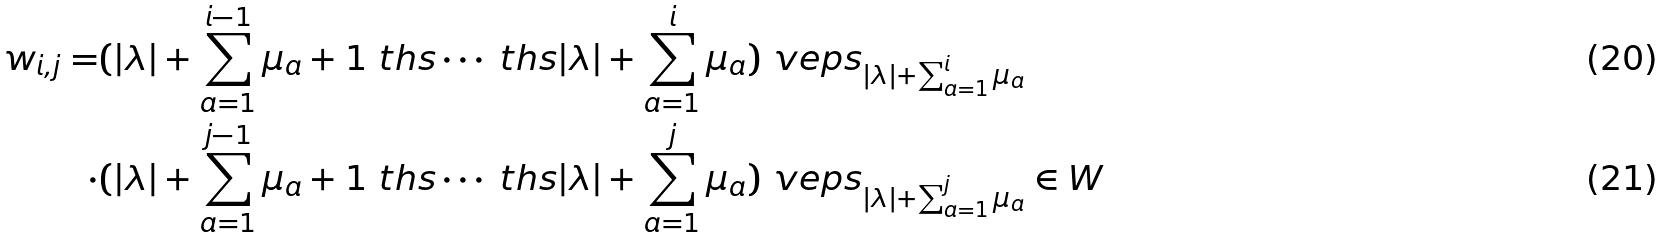<formula> <loc_0><loc_0><loc_500><loc_500>w _ { i , j } = & ( | \lambda | + \sum _ { a = 1 } ^ { i - 1 } \mu _ { a } + 1 \ t h s \cdots \ t h s | \lambda | + \sum _ { a = 1 } ^ { i } \mu _ { a } ) \ v e p s _ { | \lambda | + \sum _ { a = 1 } ^ { i } \mu _ { a } } \\ \cdot & ( | \lambda | + \sum _ { a = 1 } ^ { j - 1 } \mu _ { a } + 1 \ t h s \cdots \ t h s | \lambda | + \sum _ { a = 1 } ^ { j } \mu _ { a } ) \ v e p s _ { | \lambda | + \sum _ { a = 1 } ^ { j } \mu _ { a } } \in W</formula> 